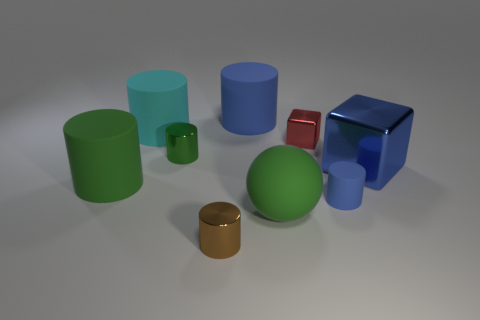There is a metal block that is the same size as the cyan rubber cylinder; what is its color?
Keep it short and to the point. Blue. What number of matte objects are small cubes or green cubes?
Your response must be concise. 0. What is the color of the small block that is made of the same material as the brown cylinder?
Offer a very short reply. Red. What is the material of the big green thing that is behind the blue rubber object that is in front of the green metallic thing?
Offer a terse response. Rubber. How many things are blue objects in front of the cyan thing or blue cylinders that are in front of the large blue shiny block?
Provide a short and direct response. 2. How big is the green metallic cylinder that is on the left side of the big cylinder that is right of the tiny shiny cylinder that is behind the large blue block?
Keep it short and to the point. Small. Is the number of large blocks that are on the left side of the small green metal cylinder the same as the number of tiny purple cubes?
Offer a terse response. Yes. Is the shape of the tiny blue matte object the same as the large green rubber thing behind the tiny rubber thing?
Give a very brief answer. Yes. There is a brown object that is the same shape as the cyan rubber object; what is its size?
Keep it short and to the point. Small. What number of other things are made of the same material as the large blue block?
Keep it short and to the point. 3. 